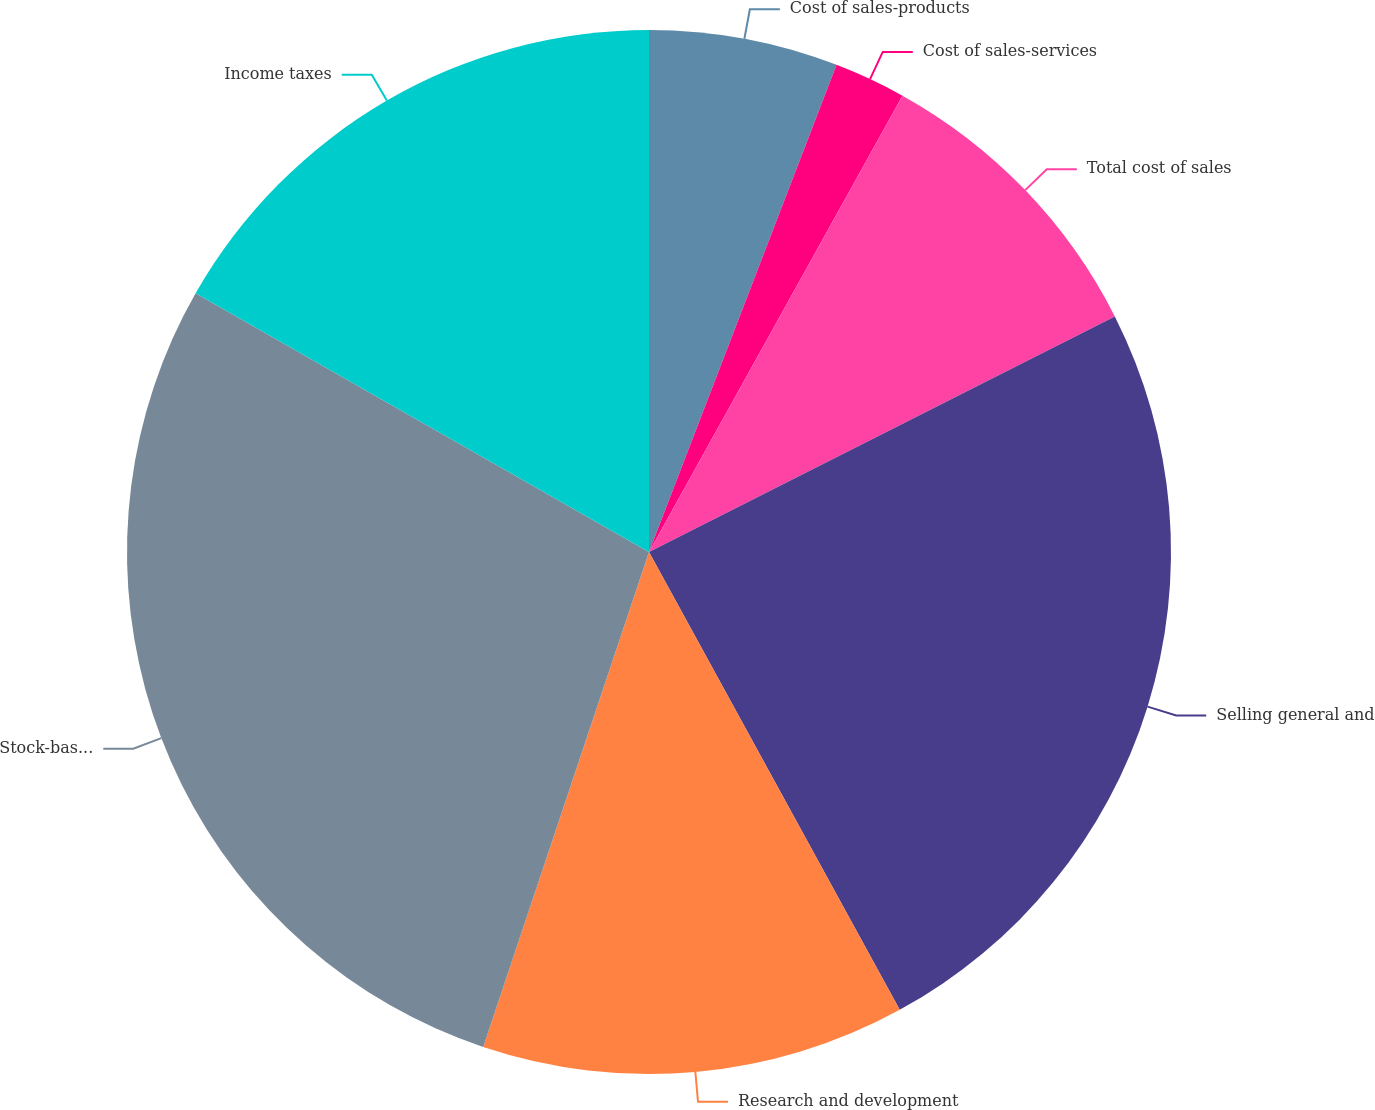<chart> <loc_0><loc_0><loc_500><loc_500><pie_chart><fcel>Cost of sales-products<fcel>Cost of sales-services<fcel>Total cost of sales<fcel>Selling general and<fcel>Research and development<fcel>Stock-based compensation<fcel>Income taxes<nl><fcel>5.85%<fcel>2.22%<fcel>9.48%<fcel>24.48%<fcel>13.12%<fcel>28.11%<fcel>16.75%<nl></chart> 